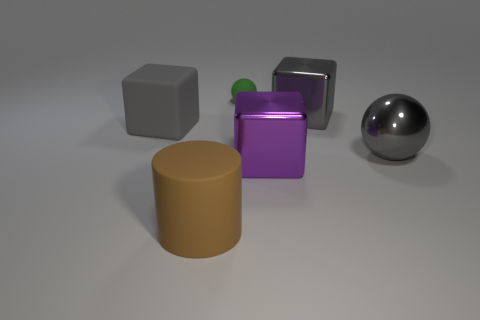Subtract all large purple blocks. How many blocks are left? 2 Add 3 big rubber things. How many objects exist? 9 Subtract all cylinders. How many objects are left? 5 Subtract all large rubber cylinders. Subtract all large metallic spheres. How many objects are left? 4 Add 4 green rubber balls. How many green rubber balls are left? 5 Add 3 big gray cubes. How many big gray cubes exist? 5 Subtract all gray cubes. How many cubes are left? 1 Subtract 0 red cubes. How many objects are left? 6 Subtract 2 blocks. How many blocks are left? 1 Subtract all cyan cylinders. Subtract all gray cubes. How many cylinders are left? 1 